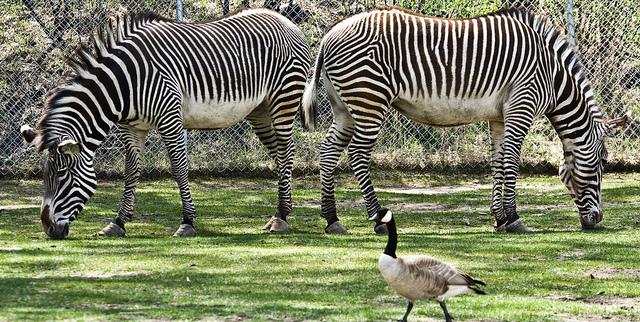What animals do you see?
Keep it brief. Zebras and goose. Does the bird like the zebras?
Give a very brief answer. Yes. Are the zebras connected at the rear end?
Write a very short answer. No. 